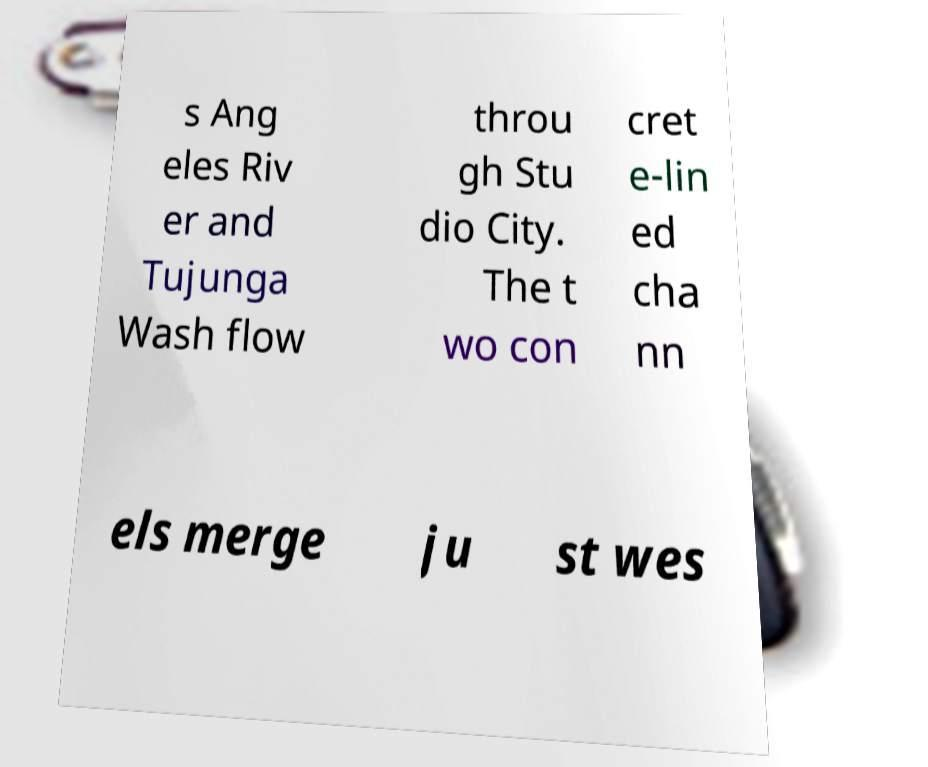Can you read and provide the text displayed in the image?This photo seems to have some interesting text. Can you extract and type it out for me? s Ang eles Riv er and Tujunga Wash flow throu gh Stu dio City. The t wo con cret e-lin ed cha nn els merge ju st wes 